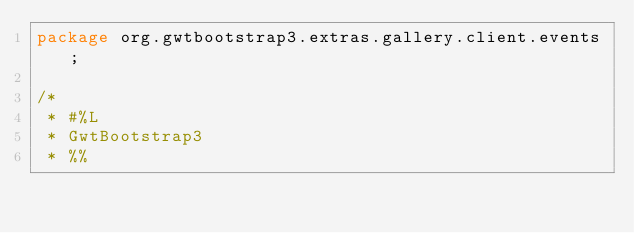Convert code to text. <code><loc_0><loc_0><loc_500><loc_500><_Java_>package org.gwtbootstrap3.extras.gallery.client.events;

/*
 * #%L
 * GwtBootstrap3
 * %%</code> 